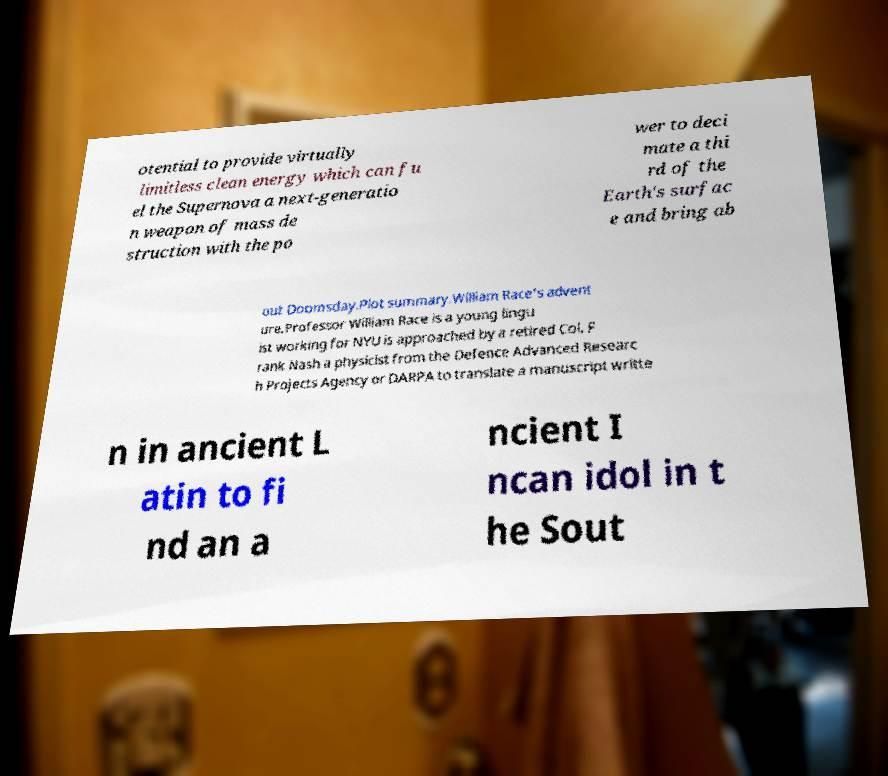Could you assist in decoding the text presented in this image and type it out clearly? otential to provide virtually limitless clean energy which can fu el the Supernova a next-generatio n weapon of mass de struction with the po wer to deci mate a thi rd of the Earth's surfac e and bring ab out Doomsday.Plot summary.William Race's advent ure.Professor William Race is a young lingu ist working for NYU is approached by a retired Col. F rank Nash a physicist from the Defence Advanced Researc h Projects Agency or DARPA to translate a manuscript writte n in ancient L atin to fi nd an a ncient I ncan idol in t he Sout 